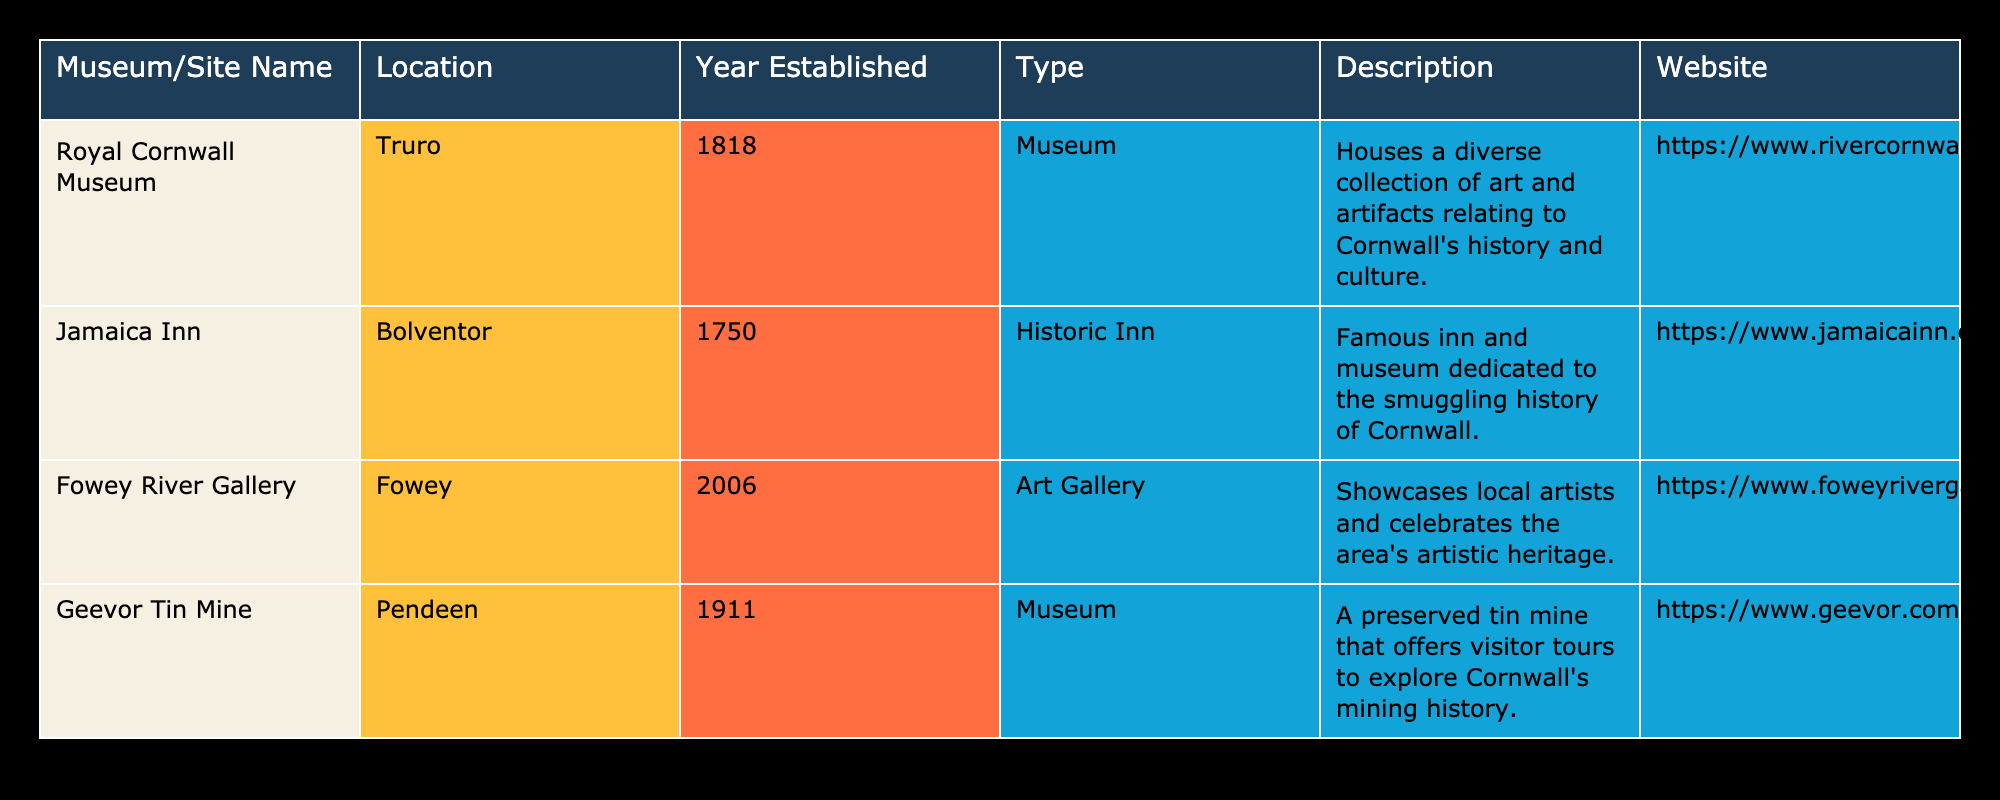What year was the Jamaica Inn established? The table lists "Jamaica Inn" under the "Museum/Site Name" column, and the corresponding "Year Established" entry is 1750.
Answer: 1750 What type of site is the Geevor Tin Mine? Referring to the "Type" column in the table, the "Geevor Tin Mine" is categorized as a museum.
Answer: Museum How many museums are listed in the table? The table includes four rows, each corresponding to a site. Among these, three are labeled as museums ("Royal Cornwall Museum," "Geevor Tin Mine," and "Jamaica Inn"). Therefore, the total number of museums is three.
Answer: 3 Which site was established most recently? We can identify the establishment years of each site: "Royal Cornwall Museum" (1818), "Jamaica Inn" (1750), "Fowey River Gallery" (2006), and "Geevor Tin Mine" (1911). The most recent year is 2006, corresponding to the "Fowey River Gallery."
Answer: Fowey River Gallery Is the Royal Cornwall Museum located in Truro? The table shows that the "Location" for "Royal Cornwall Museum" is indeed listed as Truro.
Answer: Yes What is the average year of establishment for the sites listed? To find the average year, we first note the years established: 1818, 1750, 2006, and 1911. Adding these gives: 1818 + 1750 + 2006 + 1911 = 7485. Since there are four sites, we divide by 4: 7485 / 4 = 1865.25, rounding down gives an average year of 1865 when considering whole years.
Answer: 1865 Which site has the longest history, and what is that year? By comparing the establishment years listed: "Jamaica Inn" (1750) is the earliest year compared to the others (1818, 1911, and 2006). Thus, it represents the longest history. The year is 1750.
Answer: Jamaica Inn, 1750 How many sites in the list are dedicated specifically to art? In the table, only the "Fowey River Gallery" is classified as an art gallery, which means there is just one site dedicated to art.
Answer: 1 